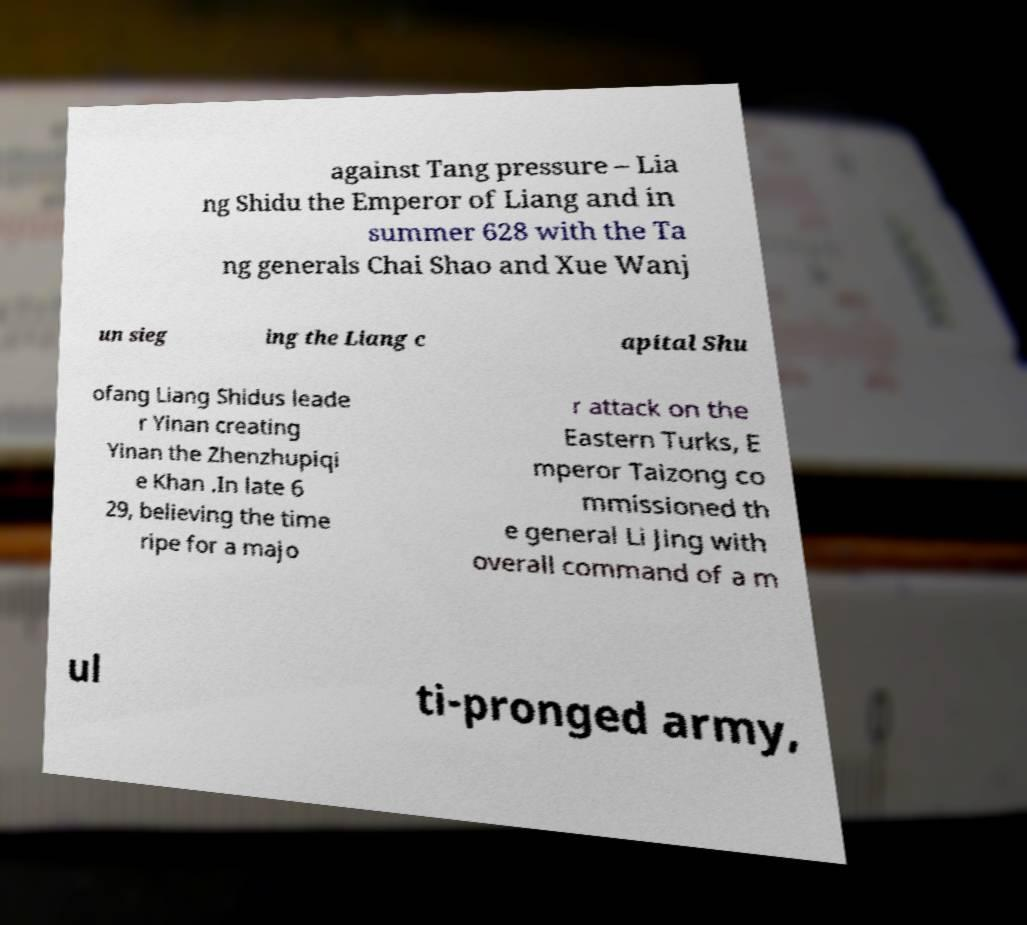Could you assist in decoding the text presented in this image and type it out clearly? against Tang pressure – Lia ng Shidu the Emperor of Liang and in summer 628 with the Ta ng generals Chai Shao and Xue Wanj un sieg ing the Liang c apital Shu ofang Liang Shidus leade r Yinan creating Yinan the Zhenzhupiqi e Khan .In late 6 29, believing the time ripe for a majo r attack on the Eastern Turks, E mperor Taizong co mmissioned th e general Li Jing with overall command of a m ul ti-pronged army, 